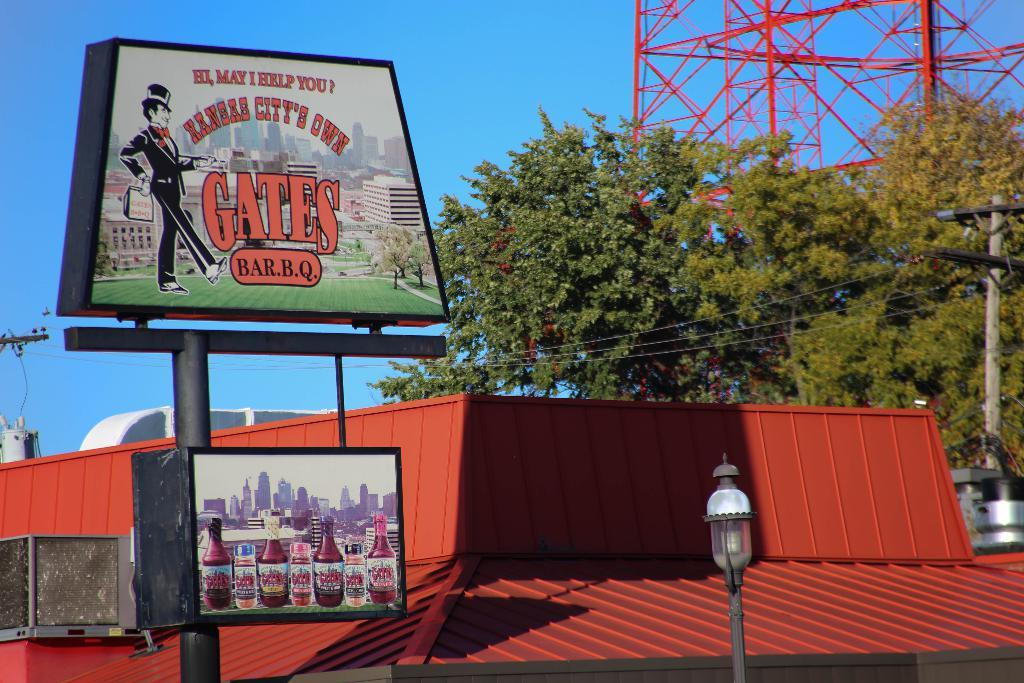Provide a one-sentence caption for the provided image. Advertisement sign on the Kansas City's Own Gates Bar BQ. 